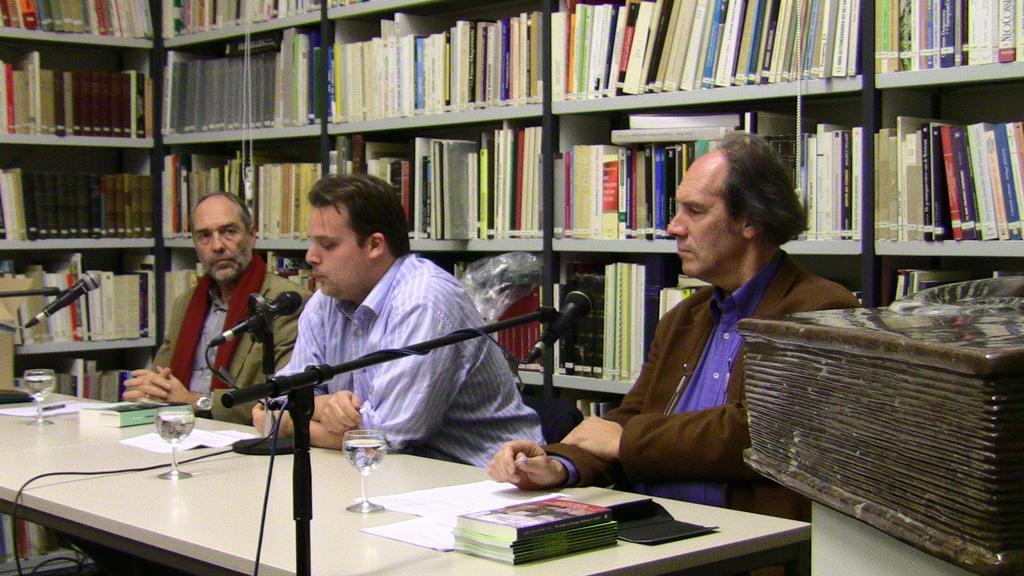Can you describe this image briefly? In this picture there are people in the center of the image, those who are sitting in front of a table, there is a table at the bottom side of the image, which contains books, glasses, and mics on it, there is a big bookshelf in the background are of the image. 